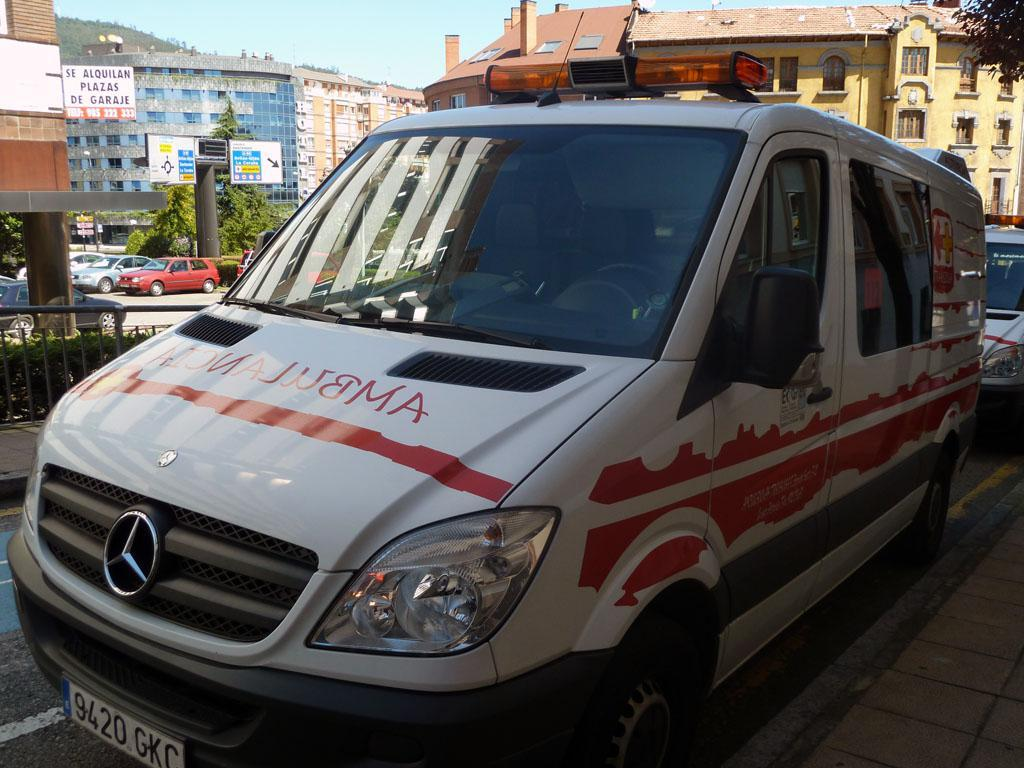<image>
Provide a brief description of the given image. A vehicle with the word ambulance written on the bonnet 